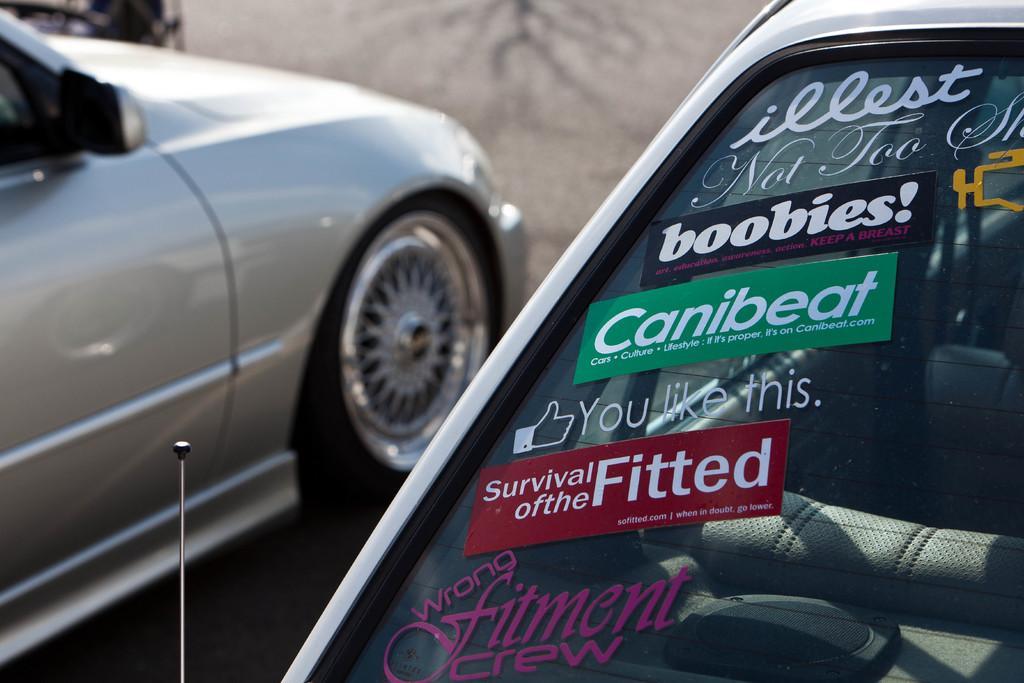Can you describe this image briefly? This image is taken outdoors. On the left side of the image a car is parked on the ground. On the right side of the image a car is parked on the ground. There are a few stickers with a text on the windshield of a car. 